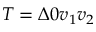Convert formula to latex. <formula><loc_0><loc_0><loc_500><loc_500>{ T = \Delta 0 v _ { 1 } v _ { 2 } }</formula> 